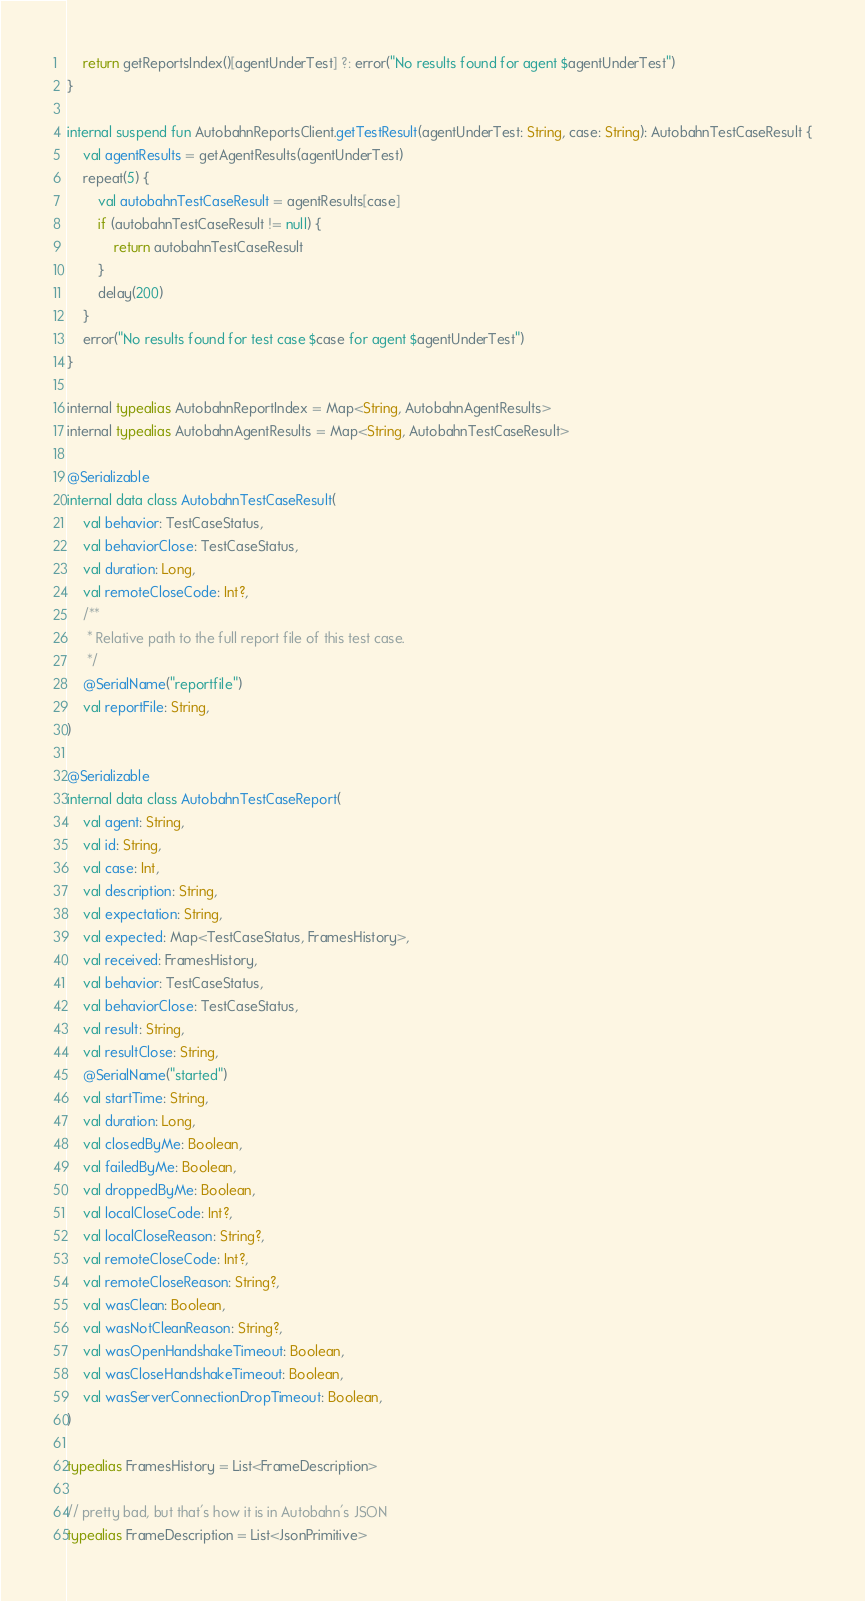Convert code to text. <code><loc_0><loc_0><loc_500><loc_500><_Kotlin_>    return getReportsIndex()[agentUnderTest] ?: error("No results found for agent $agentUnderTest")
}

internal suspend fun AutobahnReportsClient.getTestResult(agentUnderTest: String, case: String): AutobahnTestCaseResult {
    val agentResults = getAgentResults(agentUnderTest)
    repeat(5) {
        val autobahnTestCaseResult = agentResults[case]
        if (autobahnTestCaseResult != null) {
            return autobahnTestCaseResult
        }
        delay(200)
    }
    error("No results found for test case $case for agent $agentUnderTest")
}

internal typealias AutobahnReportIndex = Map<String, AutobahnAgentResults>
internal typealias AutobahnAgentResults = Map<String, AutobahnTestCaseResult>

@Serializable
internal data class AutobahnTestCaseResult(
    val behavior: TestCaseStatus,
    val behaviorClose: TestCaseStatus,
    val duration: Long,
    val remoteCloseCode: Int?,
    /**
     * Relative path to the full report file of this test case.
     */
    @SerialName("reportfile")
    val reportFile: String,
)

@Serializable
internal data class AutobahnTestCaseReport(
    val agent: String,
    val id: String,
    val case: Int,
    val description: String,
    val expectation: String,
    val expected: Map<TestCaseStatus, FramesHistory>,
    val received: FramesHistory,
    val behavior: TestCaseStatus,
    val behaviorClose: TestCaseStatus,
    val result: String,
    val resultClose: String,
    @SerialName("started")
    val startTime: String,
    val duration: Long,
    val closedByMe: Boolean,
    val failedByMe: Boolean,
    val droppedByMe: Boolean,
    val localCloseCode: Int?,
    val localCloseReason: String?,
    val remoteCloseCode: Int?,
    val remoteCloseReason: String?,
    val wasClean: Boolean,
    val wasNotCleanReason: String?,
    val wasOpenHandshakeTimeout: Boolean,
    val wasCloseHandshakeTimeout: Boolean,
    val wasServerConnectionDropTimeout: Boolean,
)

typealias FramesHistory = List<FrameDescription>

// pretty bad, but that's how it is in Autobahn's JSON
typealias FrameDescription = List<JsonPrimitive>
</code> 